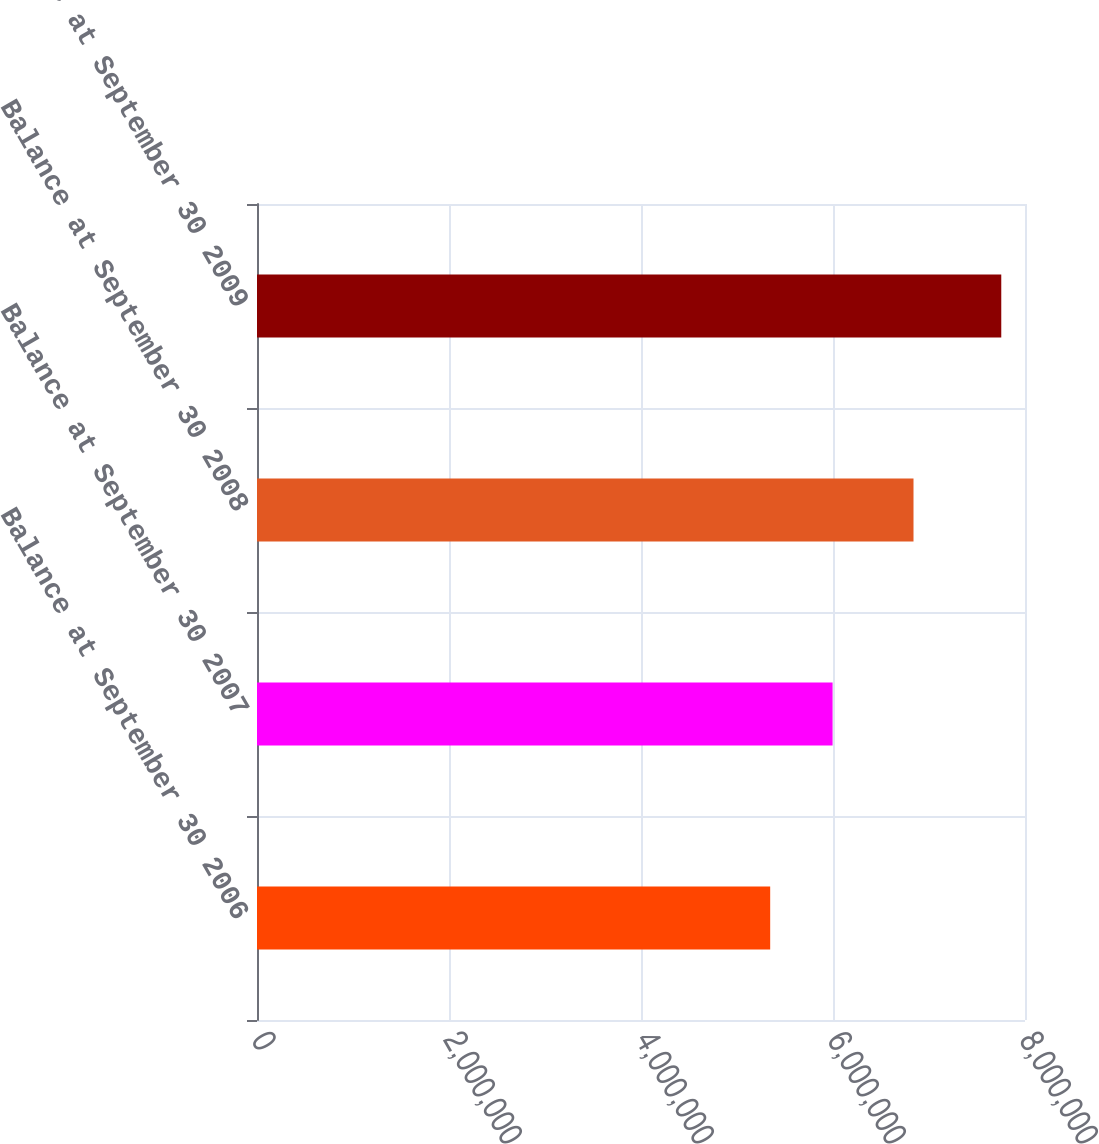<chart> <loc_0><loc_0><loc_500><loc_500><bar_chart><fcel>Balance at September 30 2006<fcel>Balance at September 30 2007<fcel>Balance at September 30 2008<fcel>Balance at September 30 2009<nl><fcel>5.3457e+06<fcel>5.99579e+06<fcel>6.83859e+06<fcel>7.75283e+06<nl></chart> 